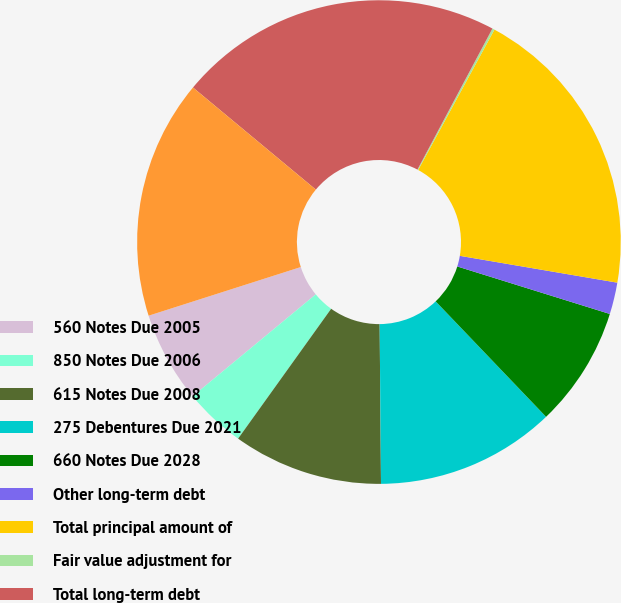Convert chart to OTSL. <chart><loc_0><loc_0><loc_500><loc_500><pie_chart><fcel>560 Notes Due 2005<fcel>850 Notes Due 2006<fcel>615 Notes Due 2008<fcel>275 Debentures Due 2021<fcel>660 Notes Due 2028<fcel>Other long-term debt<fcel>Total principal amount of<fcel>Fair value adjustment for<fcel>Total long-term debt<fcel>Less current portion<nl><fcel>6.08%<fcel>4.1%<fcel>10.03%<fcel>12.01%<fcel>8.05%<fcel>2.12%<fcel>19.76%<fcel>0.15%<fcel>21.74%<fcel>15.96%<nl></chart> 